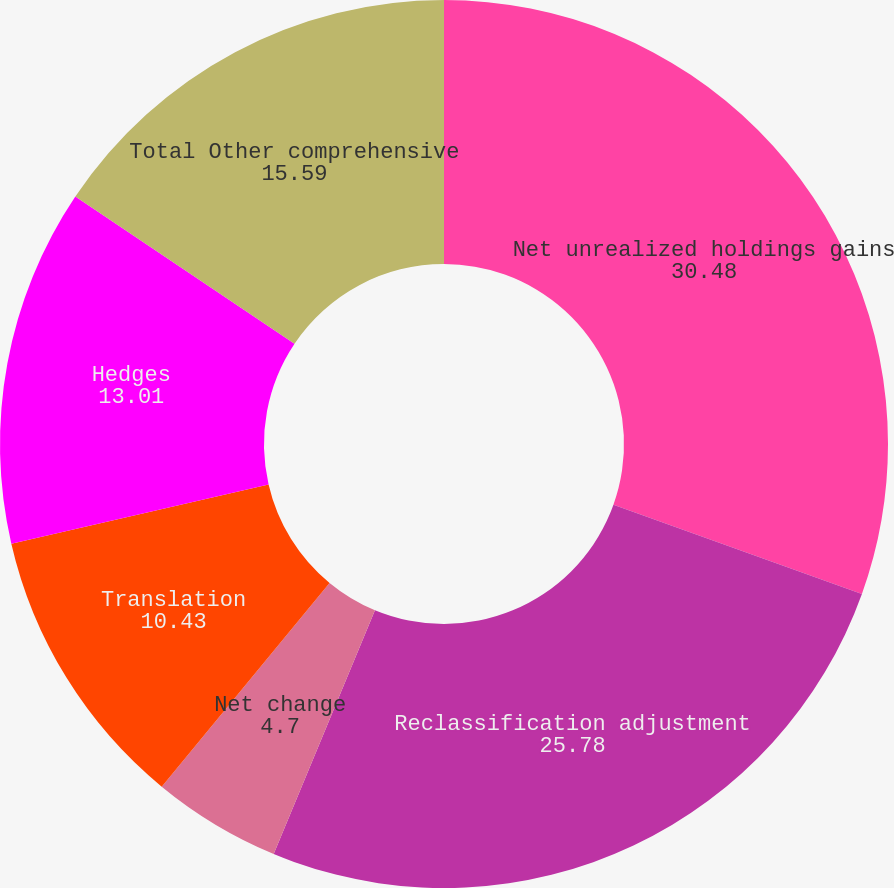Convert chart to OTSL. <chart><loc_0><loc_0><loc_500><loc_500><pie_chart><fcel>Net unrealized holdings gains<fcel>Reclassification adjustment<fcel>Net change<fcel>Translation<fcel>Hedges<fcel>Total Other comprehensive<nl><fcel>30.48%<fcel>25.78%<fcel>4.7%<fcel>10.43%<fcel>13.01%<fcel>15.59%<nl></chart> 